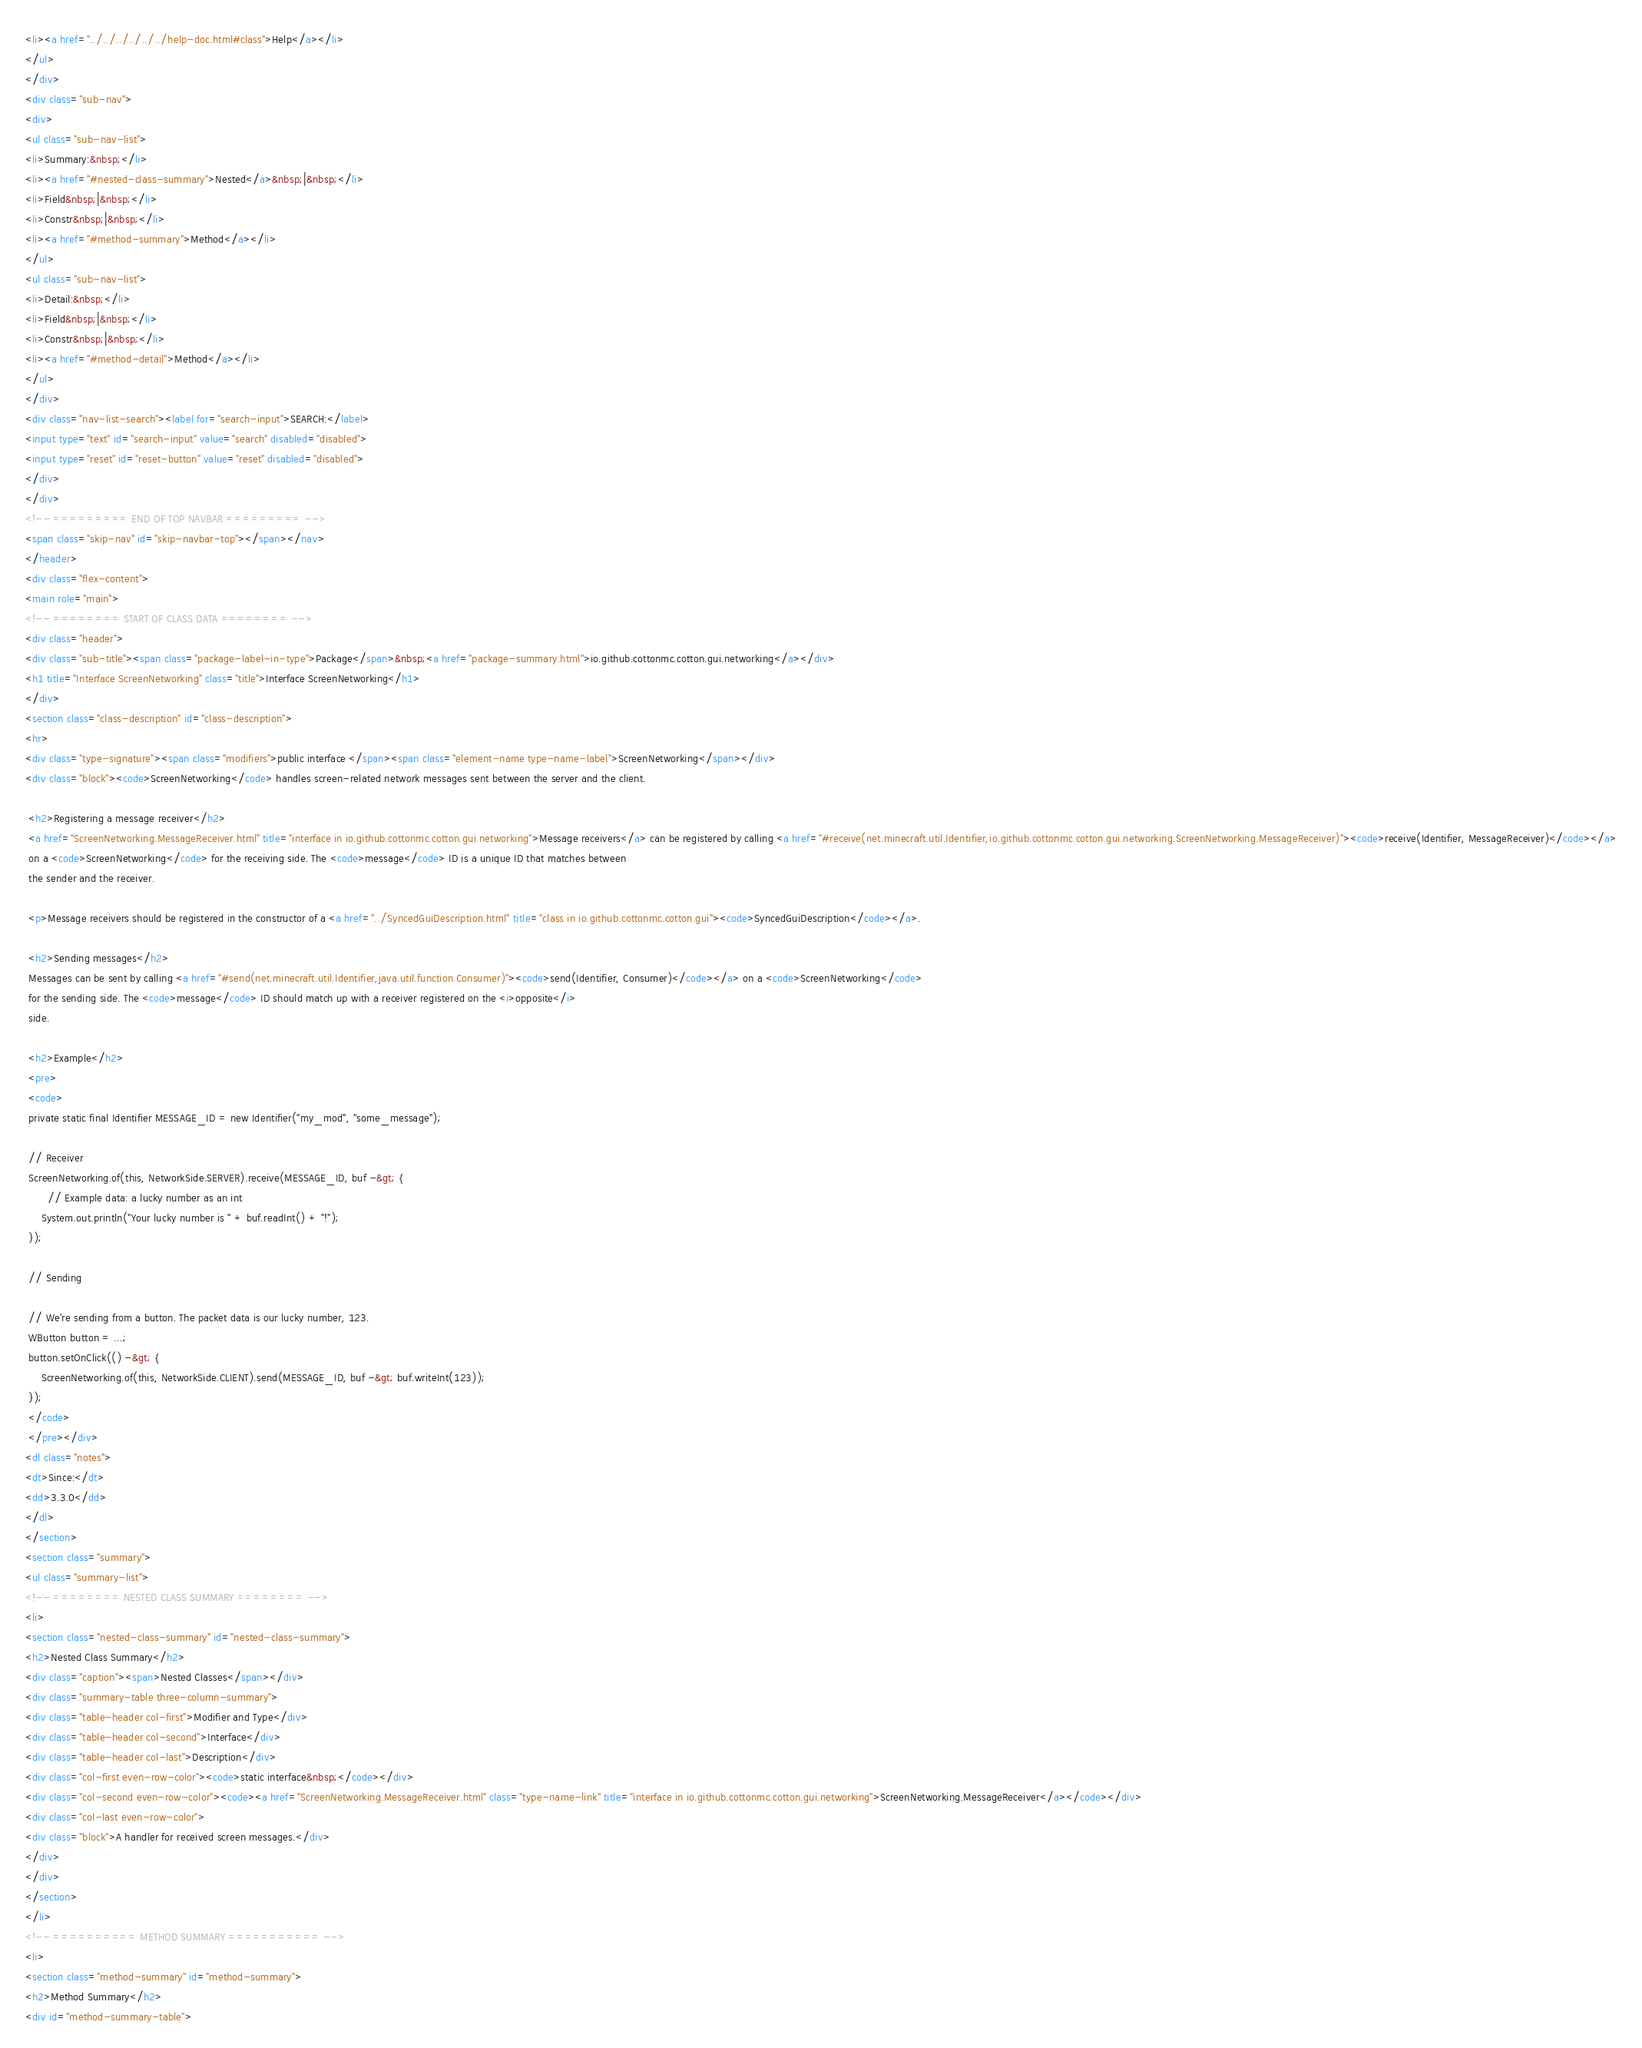<code> <loc_0><loc_0><loc_500><loc_500><_HTML_><li><a href="../../../../../../help-doc.html#class">Help</a></li>
</ul>
</div>
<div class="sub-nav">
<div>
<ul class="sub-nav-list">
<li>Summary:&nbsp;</li>
<li><a href="#nested-class-summary">Nested</a>&nbsp;|&nbsp;</li>
<li>Field&nbsp;|&nbsp;</li>
<li>Constr&nbsp;|&nbsp;</li>
<li><a href="#method-summary">Method</a></li>
</ul>
<ul class="sub-nav-list">
<li>Detail:&nbsp;</li>
<li>Field&nbsp;|&nbsp;</li>
<li>Constr&nbsp;|&nbsp;</li>
<li><a href="#method-detail">Method</a></li>
</ul>
</div>
<div class="nav-list-search"><label for="search-input">SEARCH:</label>
<input type="text" id="search-input" value="search" disabled="disabled">
<input type="reset" id="reset-button" value="reset" disabled="disabled">
</div>
</div>
<!-- ========= END OF TOP NAVBAR ========= -->
<span class="skip-nav" id="skip-navbar-top"></span></nav>
</header>
<div class="flex-content">
<main role="main">
<!-- ======== START OF CLASS DATA ======== -->
<div class="header">
<div class="sub-title"><span class="package-label-in-type">Package</span>&nbsp;<a href="package-summary.html">io.github.cottonmc.cotton.gui.networking</a></div>
<h1 title="Interface ScreenNetworking" class="title">Interface ScreenNetworking</h1>
</div>
<section class="class-description" id="class-description">
<hr>
<div class="type-signature"><span class="modifiers">public interface </span><span class="element-name type-name-label">ScreenNetworking</span></div>
<div class="block"><code>ScreenNetworking</code> handles screen-related network messages sent between the server and the client.

 <h2>Registering a message receiver</h2>
 <a href="ScreenNetworking.MessageReceiver.html" title="interface in io.github.cottonmc.cotton.gui.networking">Message receivers</a> can be registered by calling <a href="#receive(net.minecraft.util.Identifier,io.github.cottonmc.cotton.gui.networking.ScreenNetworking.MessageReceiver)"><code>receive(Identifier, MessageReceiver)</code></a>
 on a <code>ScreenNetworking</code> for the receiving side. The <code>message</code> ID is a unique ID that matches between
 the sender and the receiver.

 <p>Message receivers should be registered in the constructor of a <a href="../SyncedGuiDescription.html" title="class in io.github.cottonmc.cotton.gui"><code>SyncedGuiDescription</code></a>.

 <h2>Sending messages</h2>
 Messages can be sent by calling <a href="#send(net.minecraft.util.Identifier,java.util.function.Consumer)"><code>send(Identifier, Consumer)</code></a> on a <code>ScreenNetworking</code>
 for the sending side. The <code>message</code> ID should match up with a receiver registered on the <i>opposite</i>
 side.

 <h2>Example</h2>
 <pre>
 <code>
 private static final Identifier MESSAGE_ID = new Identifier("my_mod", "some_message");

 // Receiver
 ScreenNetworking.of(this, NetworkSide.SERVER).receive(MESSAGE_ID, buf -&gt; {
 	   // Example data: a lucky number as an int
     System.out.println("Your lucky number is " + buf.readInt() + "!");
 });

 // Sending

 // We're sending from a button. The packet data is our lucky number, 123.
 WButton button = ...;
 button.setOnClick(() -&gt; {
     ScreenNetworking.of(this, NetworkSide.CLIENT).send(MESSAGE_ID, buf -&gt; buf.writeInt(123));
 });
 </code>
 </pre></div>
<dl class="notes">
<dt>Since:</dt>
<dd>3.3.0</dd>
</dl>
</section>
<section class="summary">
<ul class="summary-list">
<!-- ======== NESTED CLASS SUMMARY ======== -->
<li>
<section class="nested-class-summary" id="nested-class-summary">
<h2>Nested Class Summary</h2>
<div class="caption"><span>Nested Classes</span></div>
<div class="summary-table three-column-summary">
<div class="table-header col-first">Modifier and Type</div>
<div class="table-header col-second">Interface</div>
<div class="table-header col-last">Description</div>
<div class="col-first even-row-color"><code>static interface&nbsp;</code></div>
<div class="col-second even-row-color"><code><a href="ScreenNetworking.MessageReceiver.html" class="type-name-link" title="interface in io.github.cottonmc.cotton.gui.networking">ScreenNetworking.MessageReceiver</a></code></div>
<div class="col-last even-row-color">
<div class="block">A handler for received screen messages.</div>
</div>
</div>
</section>
</li>
<!-- ========== METHOD SUMMARY =========== -->
<li>
<section class="method-summary" id="method-summary">
<h2>Method Summary</h2>
<div id="method-summary-table"></code> 